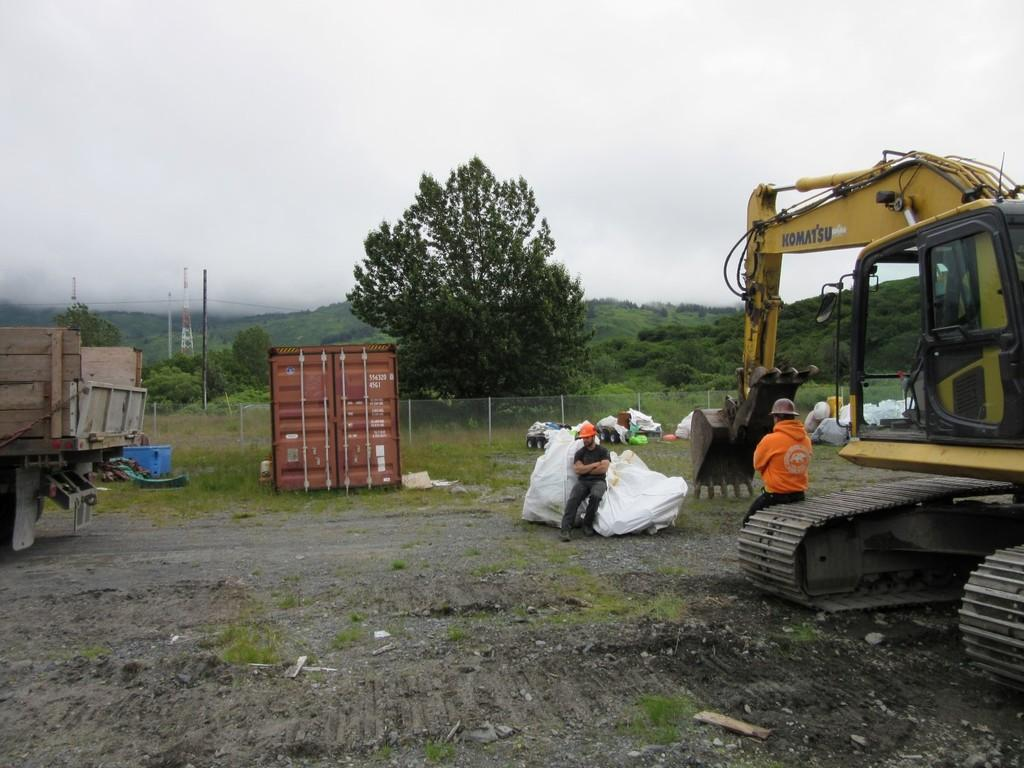<image>
Describe the image concisely. a man sitting on the belt of a Komatsu machine 